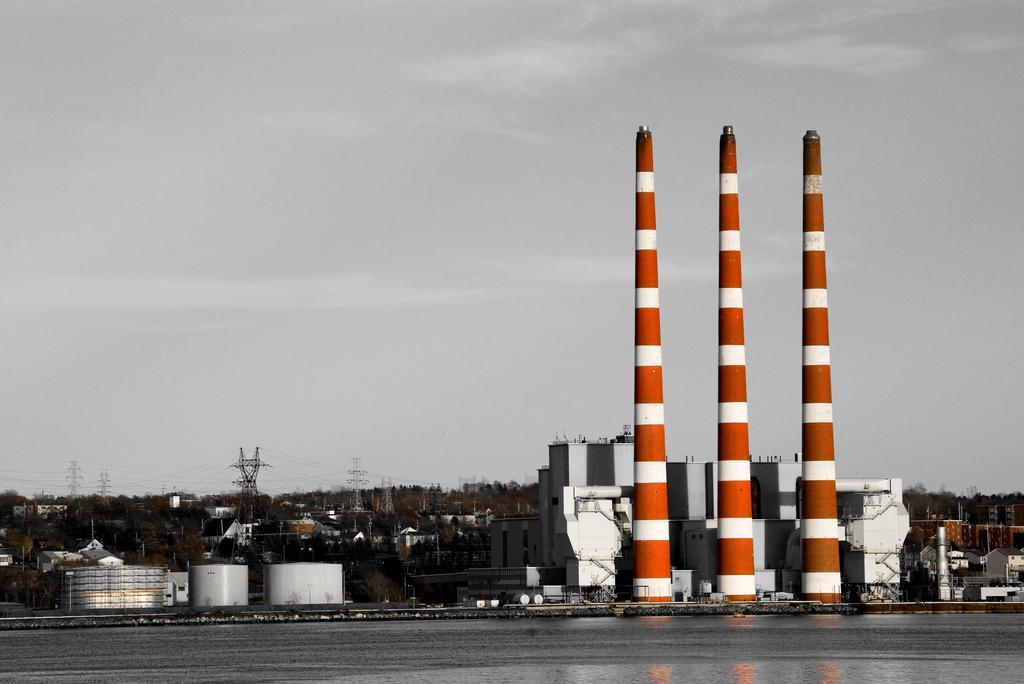Describe this image in one or two sentences. In this image I can see on the right side it looks there are exhaust pipes. On the left side it looks like there are containers, at the back side there are trees and electric poles. At the top it is the sky, at the bottom there is water. 